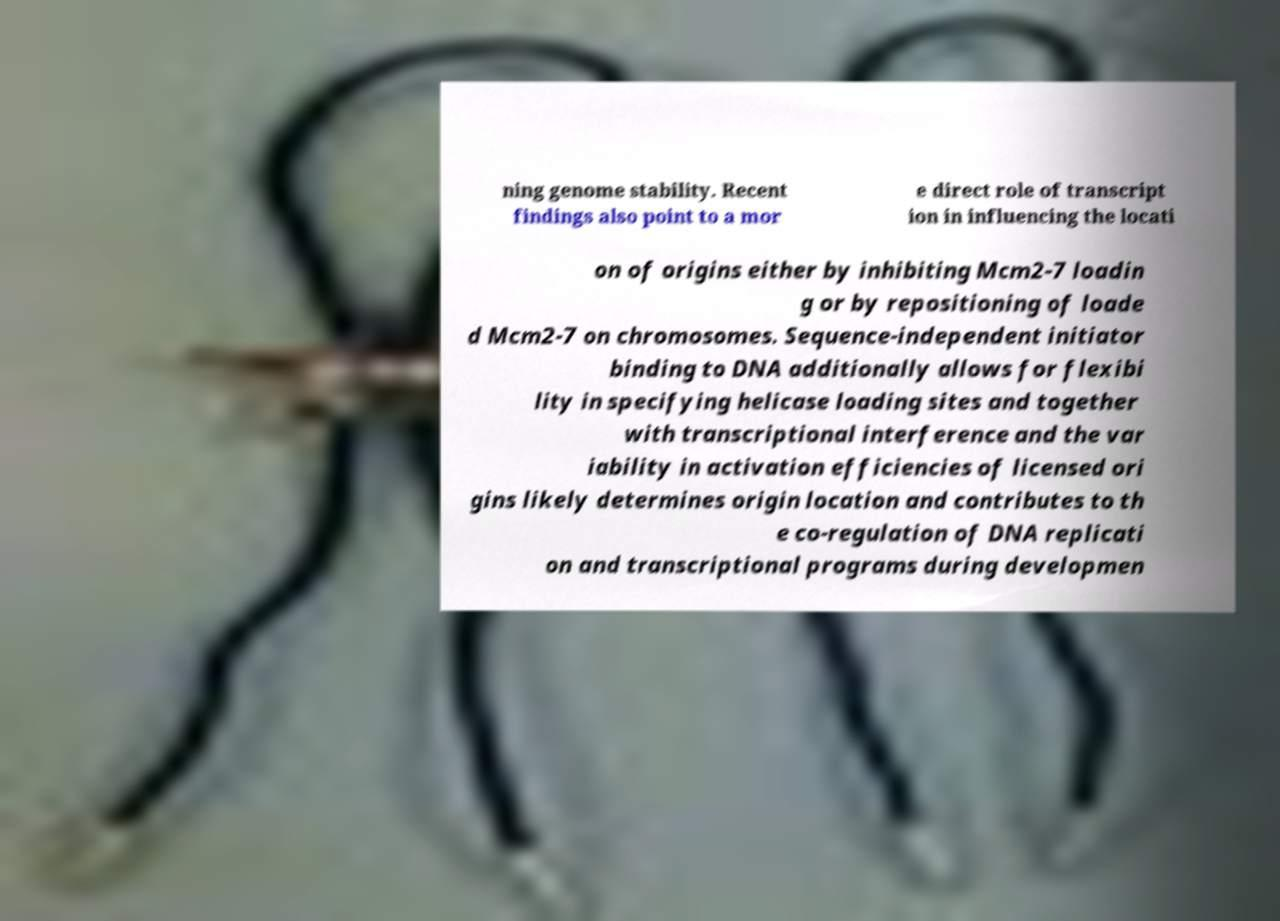For documentation purposes, I need the text within this image transcribed. Could you provide that? ning genome stability. Recent findings also point to a mor e direct role of transcript ion in influencing the locati on of origins either by inhibiting Mcm2-7 loadin g or by repositioning of loade d Mcm2-7 on chromosomes. Sequence-independent initiator binding to DNA additionally allows for flexibi lity in specifying helicase loading sites and together with transcriptional interference and the var iability in activation efficiencies of licensed ori gins likely determines origin location and contributes to th e co-regulation of DNA replicati on and transcriptional programs during developmen 